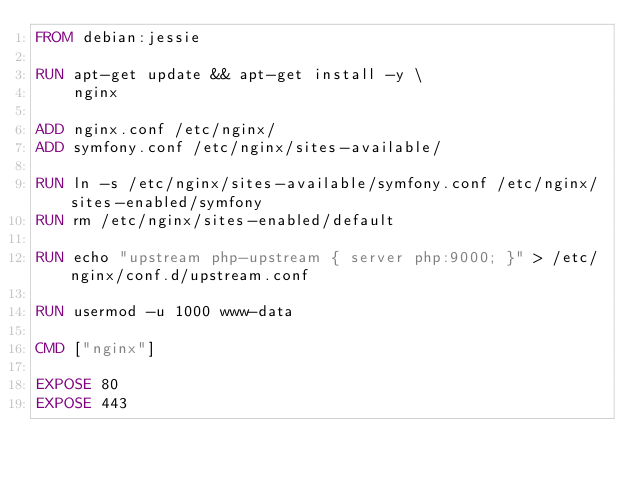<code> <loc_0><loc_0><loc_500><loc_500><_Dockerfile_>FROM debian:jessie

RUN apt-get update && apt-get install -y \
    nginx

ADD nginx.conf /etc/nginx/
ADD symfony.conf /etc/nginx/sites-available/

RUN ln -s /etc/nginx/sites-available/symfony.conf /etc/nginx/sites-enabled/symfony
RUN rm /etc/nginx/sites-enabled/default

RUN echo "upstream php-upstream { server php:9000; }" > /etc/nginx/conf.d/upstream.conf

RUN usermod -u 1000 www-data

CMD ["nginx"]

EXPOSE 80
EXPOSE 443</code> 